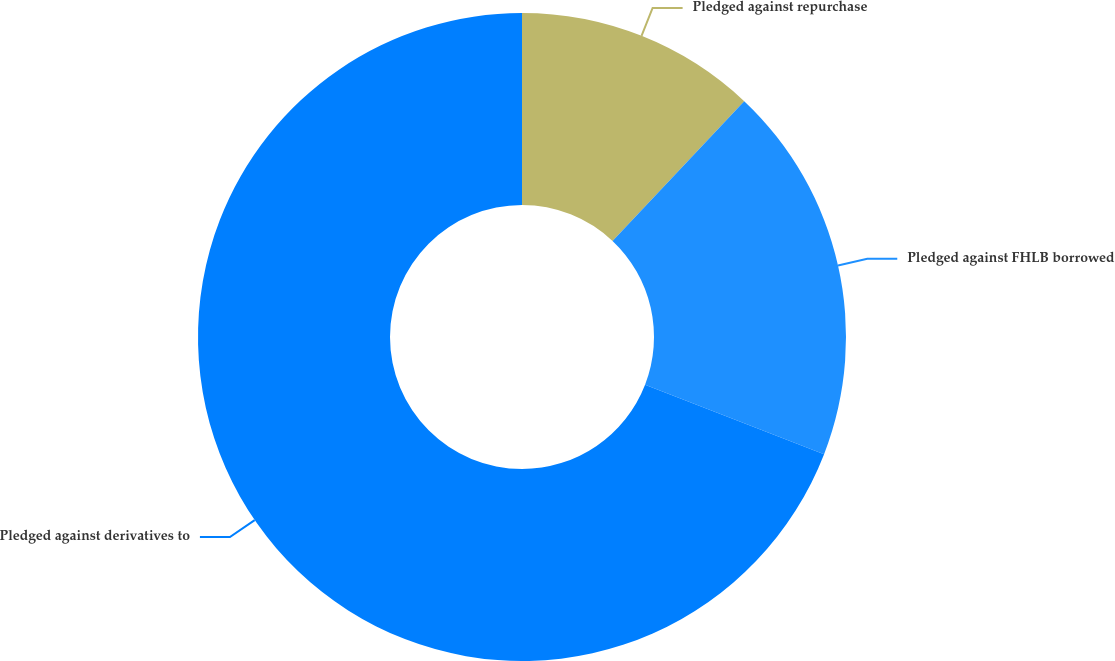Convert chart to OTSL. <chart><loc_0><loc_0><loc_500><loc_500><pie_chart><fcel>Pledged against repurchase<fcel>Pledged against FHLB borrowed<fcel>Pledged against derivatives to<nl><fcel>12.03%<fcel>18.86%<fcel>69.12%<nl></chart> 